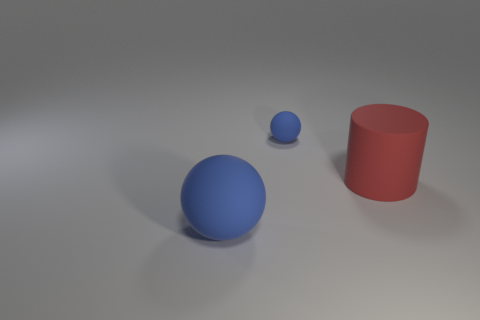Add 2 big green shiny balls. How many objects exist? 5 Subtract all balls. How many objects are left? 1 Subtract 0 purple blocks. How many objects are left? 3 Subtract all rubber cylinders. Subtract all large red things. How many objects are left? 1 Add 1 small rubber spheres. How many small rubber spheres are left? 2 Add 1 large red objects. How many large red objects exist? 2 